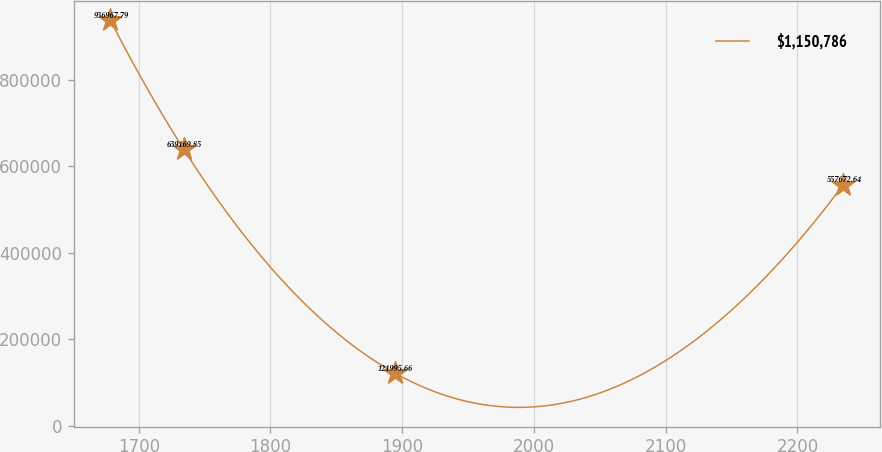<chart> <loc_0><loc_0><loc_500><loc_500><line_chart><ecel><fcel>$1,150,786<nl><fcel>1678.5<fcel>936968<nl><fcel>1734.14<fcel>639170<nl><fcel>1894.41<fcel>121996<nl><fcel>2234.93<fcel>557673<nl></chart> 